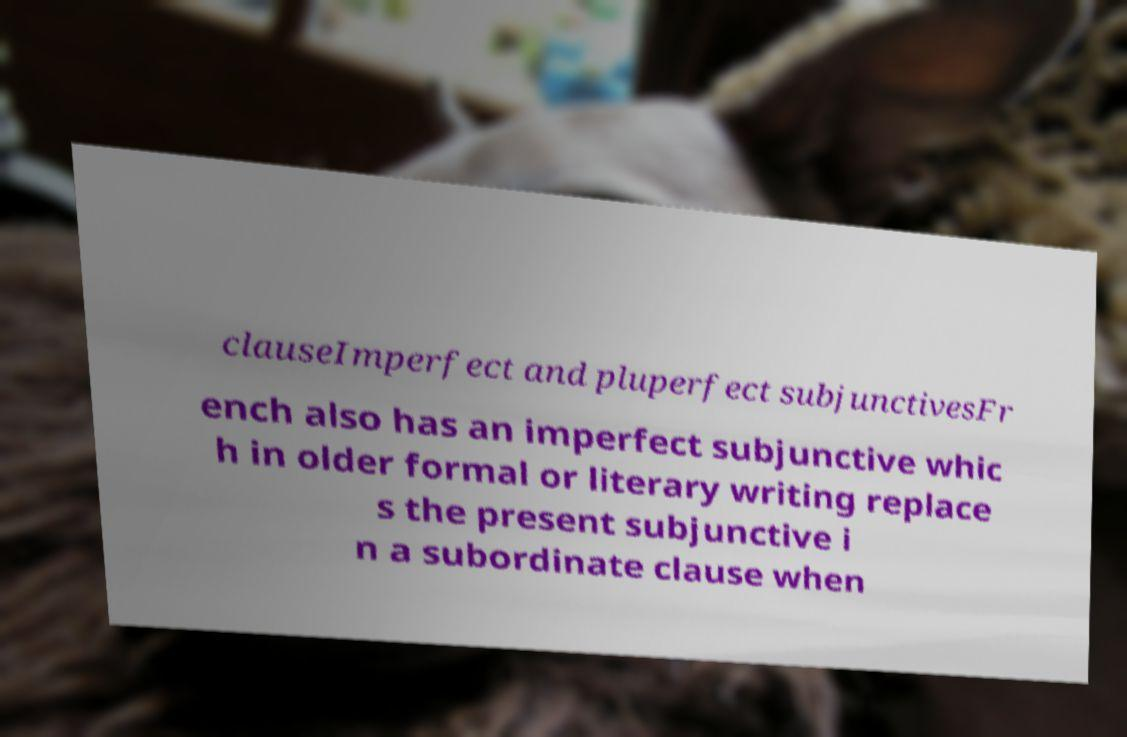Can you read and provide the text displayed in the image?This photo seems to have some interesting text. Can you extract and type it out for me? clauseImperfect and pluperfect subjunctivesFr ench also has an imperfect subjunctive whic h in older formal or literary writing replace s the present subjunctive i n a subordinate clause when 